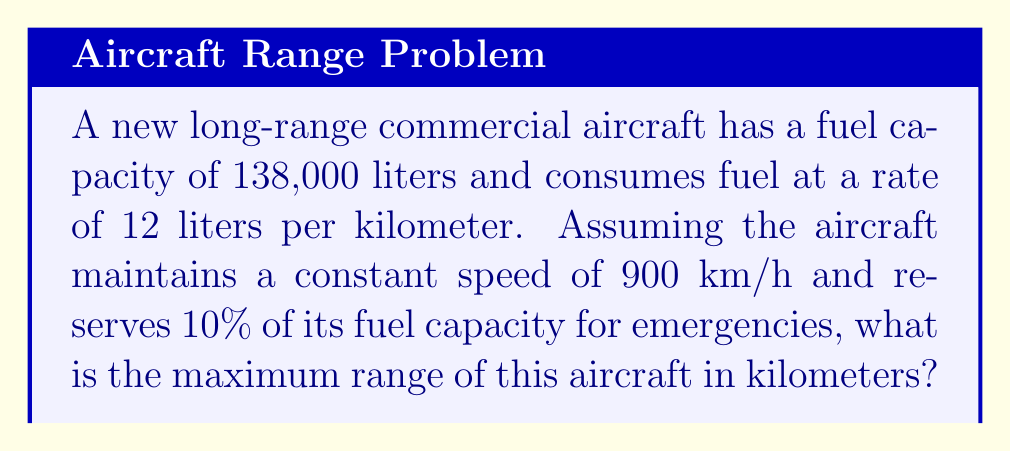Help me with this question. To solve this problem, we'll follow these steps:

1. Calculate the usable fuel:
   Total fuel capacity = 138,000 liters
   Emergency reserve = 10% = 0.1 × 138,000 = 13,800 liters
   Usable fuel = 138,000 - 13,800 = 124,200 liters

2. Calculate the range:
   Fuel consumption rate = 12 liters/km
   Range = Usable fuel ÷ Fuel consumption rate
   
   $$\text{Range} = \frac{124,200 \text{ liters}}{12 \text{ liters/km}} = 10,350 \text{ km}$$

3. Verify the flight time:
   Speed = 900 km/h
   Time = Range ÷ Speed
   
   $$\text{Time} = \frac{10,350 \text{ km}}{900 \text{ km/h}} = 11.5 \text{ hours}$$

This flight time is reasonable for a long-range commercial aircraft, confirming our calculation.
Answer: 10,350 km 